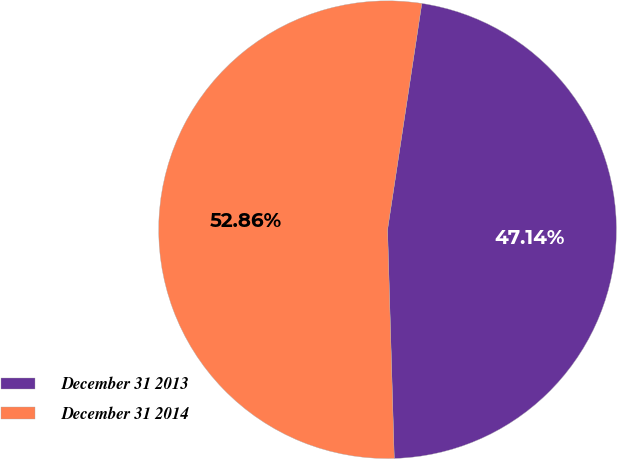Convert chart to OTSL. <chart><loc_0><loc_0><loc_500><loc_500><pie_chart><fcel>December 31 2013<fcel>December 31 2014<nl><fcel>47.14%<fcel>52.86%<nl></chart> 